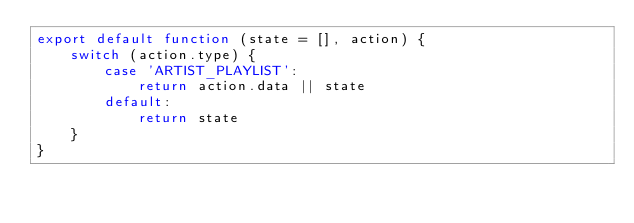Convert code to text. <code><loc_0><loc_0><loc_500><loc_500><_JavaScript_>export default function (state = [], action) {
    switch (action.type) {
        case 'ARTIST_PLAYLIST':
            return action.data || state
        default:
            return state
    }
}
</code> 